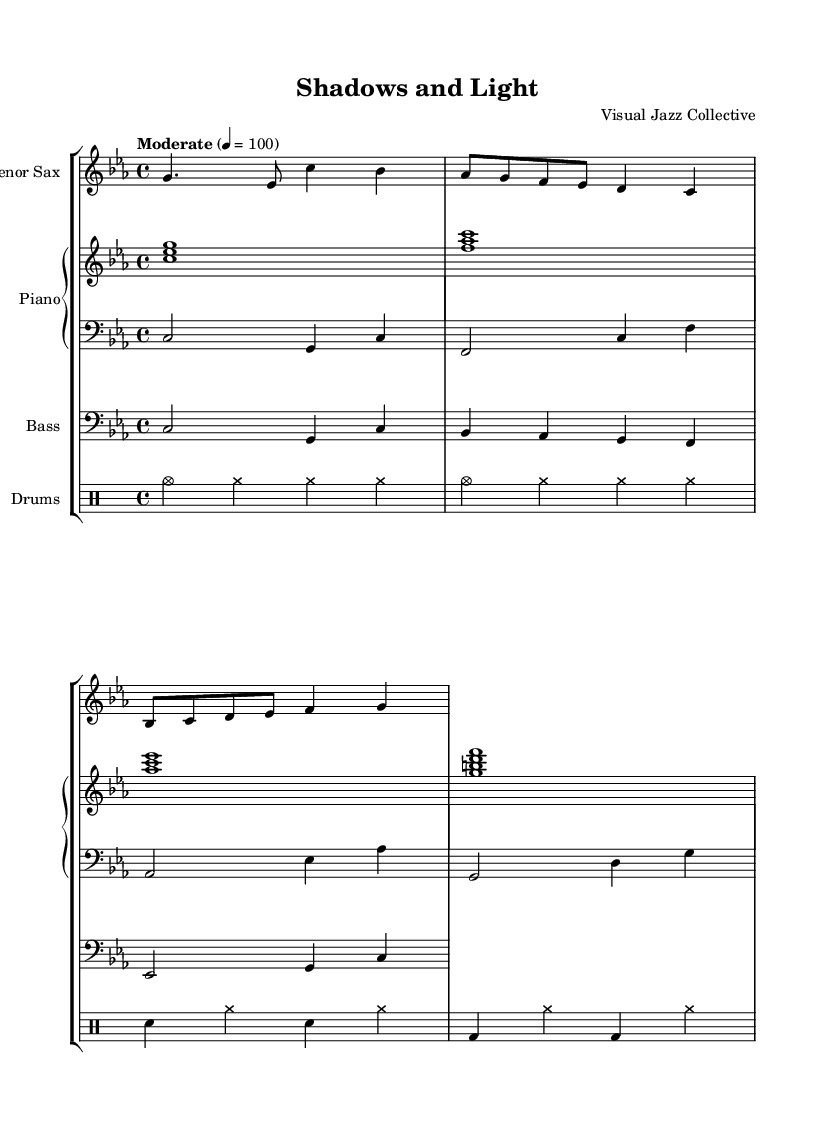What is the key signature of this music? The key signature is C minor, indicated by three flats (B♭, E♭, A♭) at the beginning of the staff.
Answer: C minor What is the time signature of this piece? The time signature is 4/4, which is seen at the beginning of the music and means there are four beats per measure.
Answer: 4/4 What is the tempo marking for this piece? The tempo marking is "Moderate," indicating the desired speed of the piece, alongside the metronome marking of quarter note = 100.
Answer: Moderate How many instruments are included in the ensemble? There are four instruments included in the ensemble: tenor saxophone, piano (with right and left hand parts), bass, and drums, each represented by a staff.
Answer: Four What is the primary texture of the piece? The primary texture is homophonic, as the melody (saxophone) is supported by accompanying harmonies from the piano, bass, and rhythmic patterns from the drums.
Answer: Homophonic Which instrument plays the melody in this piece? The melody is played by the tenor saxophone, which is indicated by the first staff labeled "Tenor Sax."
Answer: Tenor Sax 